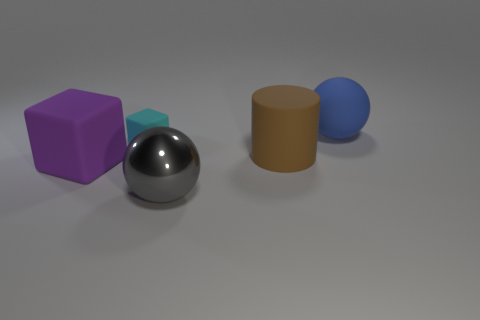Is the shape of the tiny cyan rubber thing the same as the big thing that is left of the big gray shiny ball?
Give a very brief answer. Yes. What is the big cylinder made of?
Offer a terse response. Rubber. There is a big ball that is left of the ball that is behind the sphere that is on the left side of the large blue thing; what color is it?
Keep it short and to the point. Gray. What material is the tiny cyan thing that is the same shape as the big purple thing?
Your answer should be compact. Rubber. What number of cyan rubber things have the same size as the blue rubber thing?
Your response must be concise. 0. How many tiny purple metal blocks are there?
Offer a very short reply. 0. Do the large purple block and the small thing that is behind the metallic thing have the same material?
Your response must be concise. Yes. How many yellow things are rubber cubes or small blocks?
Keep it short and to the point. 0. The blue object that is the same material as the large cylinder is what size?
Give a very brief answer. Large. How many other things are the same shape as the purple matte thing?
Provide a short and direct response. 1. 